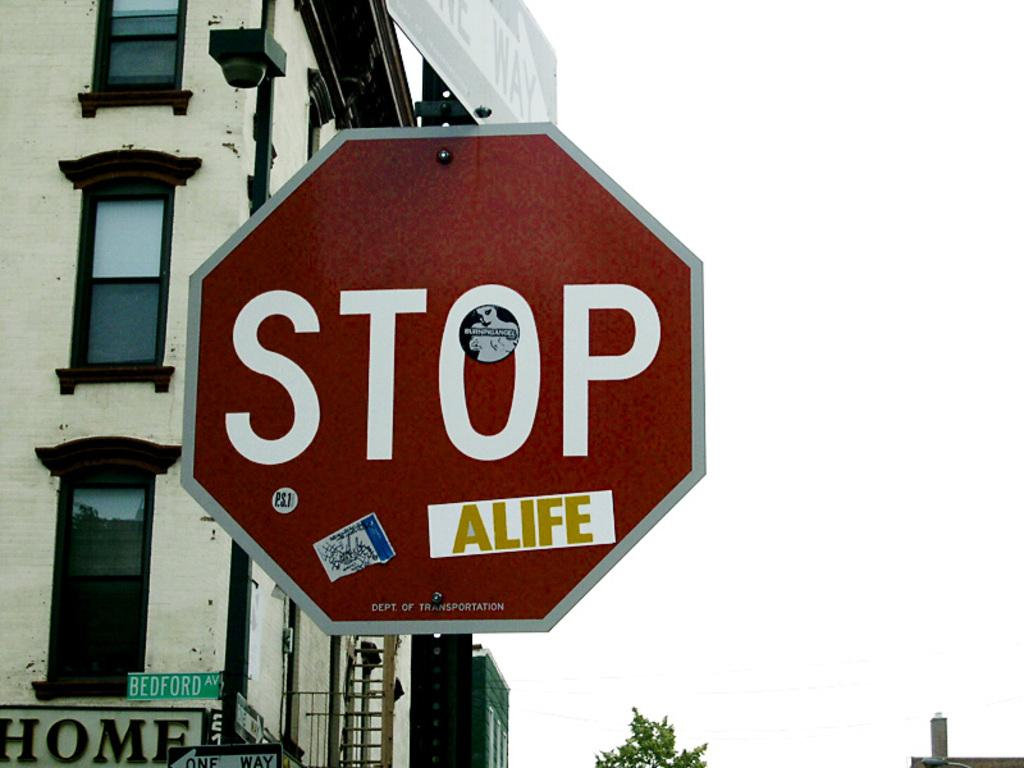Provide a one-sentence caption for the provided image. A sticker attached to a road sign amends the message to read Stop A Life. 